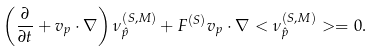Convert formula to latex. <formula><loc_0><loc_0><loc_500><loc_500>\left ( \frac { \partial } { \partial t } + { v } _ { p } \cdot { \nabla } \right ) \nu ^ { ( S , M ) } _ { \hat { p } } + F ^ { ( S ) } { v } _ { p } \cdot { \nabla } < \nu ^ { ( S , M ) } _ { \hat { p } } > = 0 .</formula> 